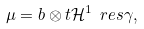<formula> <loc_0><loc_0><loc_500><loc_500>\mu = b \otimes t \mathcal { H } ^ { 1 } \ r e s \gamma ,</formula> 